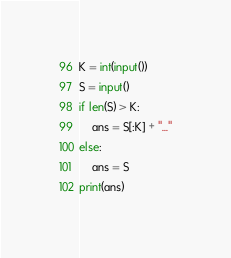Convert code to text. <code><loc_0><loc_0><loc_500><loc_500><_Python_>K = int(input())
S = input()
if len(S) > K:
    ans = S[:K] + "..."
else:
    ans = S
print(ans)
</code> 